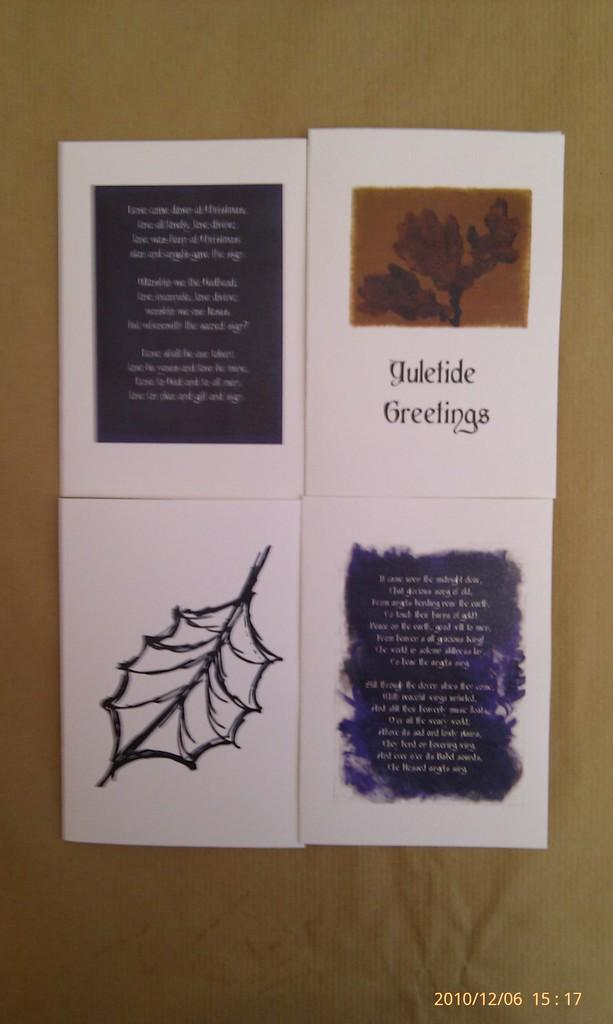How many papers can be seen in the image? There are four papers in the image. What is the color of the surface on which the papers are pasted? The papers are pasted on a brown surface. Where is the brown surface located in the image? The brown surface is in the foreground of the image. What title is written on the top of the brown surface in the image? There is no title written on the top of the brown surface in the image. Is there a bath visible in the image? There is no bath present in the image. 